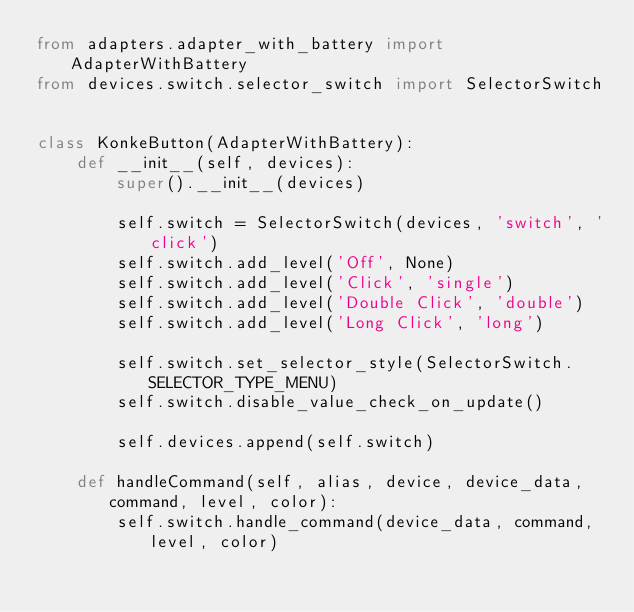<code> <loc_0><loc_0><loc_500><loc_500><_Python_>from adapters.adapter_with_battery import AdapterWithBattery
from devices.switch.selector_switch import SelectorSwitch


class KonkeButton(AdapterWithBattery):
    def __init__(self, devices):
        super().__init__(devices)

        self.switch = SelectorSwitch(devices, 'switch', 'click')
        self.switch.add_level('Off', None)
        self.switch.add_level('Click', 'single')
        self.switch.add_level('Double Click', 'double')
        self.switch.add_level('Long Click', 'long')

        self.switch.set_selector_style(SelectorSwitch.SELECTOR_TYPE_MENU)
        self.switch.disable_value_check_on_update()

        self.devices.append(self.switch)

    def handleCommand(self, alias, device, device_data, command, level, color):
        self.switch.handle_command(device_data, command, level, color)
</code> 